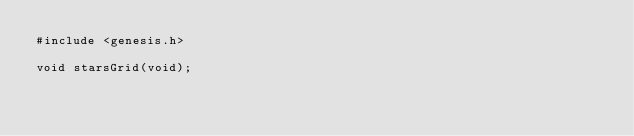Convert code to text. <code><loc_0><loc_0><loc_500><loc_500><_C_>#include <genesis.h>

void starsGrid(void);
</code> 